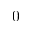<formula> <loc_0><loc_0><loc_500><loc_500>0</formula> 